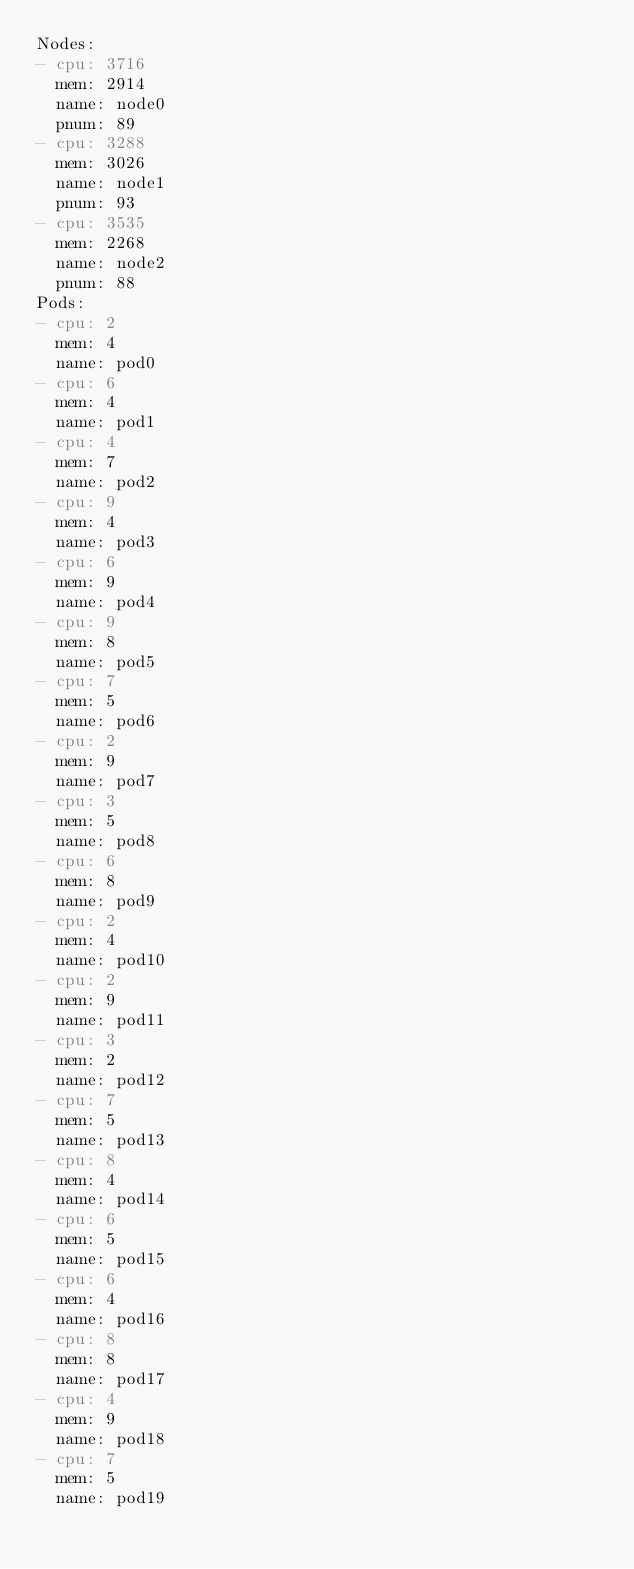<code> <loc_0><loc_0><loc_500><loc_500><_YAML_>Nodes:
- cpu: 3716
  mem: 2914
  name: node0
  pnum: 89
- cpu: 3288
  mem: 3026
  name: node1
  pnum: 93
- cpu: 3535
  mem: 2268
  name: node2
  pnum: 88
Pods:
- cpu: 2
  mem: 4
  name: pod0
- cpu: 6
  mem: 4
  name: pod1
- cpu: 4
  mem: 7
  name: pod2
- cpu: 9
  mem: 4
  name: pod3
- cpu: 6
  mem: 9
  name: pod4
- cpu: 9
  mem: 8
  name: pod5
- cpu: 7
  mem: 5
  name: pod6
- cpu: 2
  mem: 9
  name: pod7
- cpu: 3
  mem: 5
  name: pod8
- cpu: 6
  mem: 8
  name: pod9
- cpu: 2
  mem: 4
  name: pod10
- cpu: 2
  mem: 9
  name: pod11
- cpu: 3
  mem: 2
  name: pod12
- cpu: 7
  mem: 5
  name: pod13
- cpu: 8
  mem: 4
  name: pod14
- cpu: 6
  mem: 5
  name: pod15
- cpu: 6
  mem: 4
  name: pod16
- cpu: 8
  mem: 8
  name: pod17
- cpu: 4
  mem: 9
  name: pod18
- cpu: 7
  mem: 5
  name: pod19
</code> 